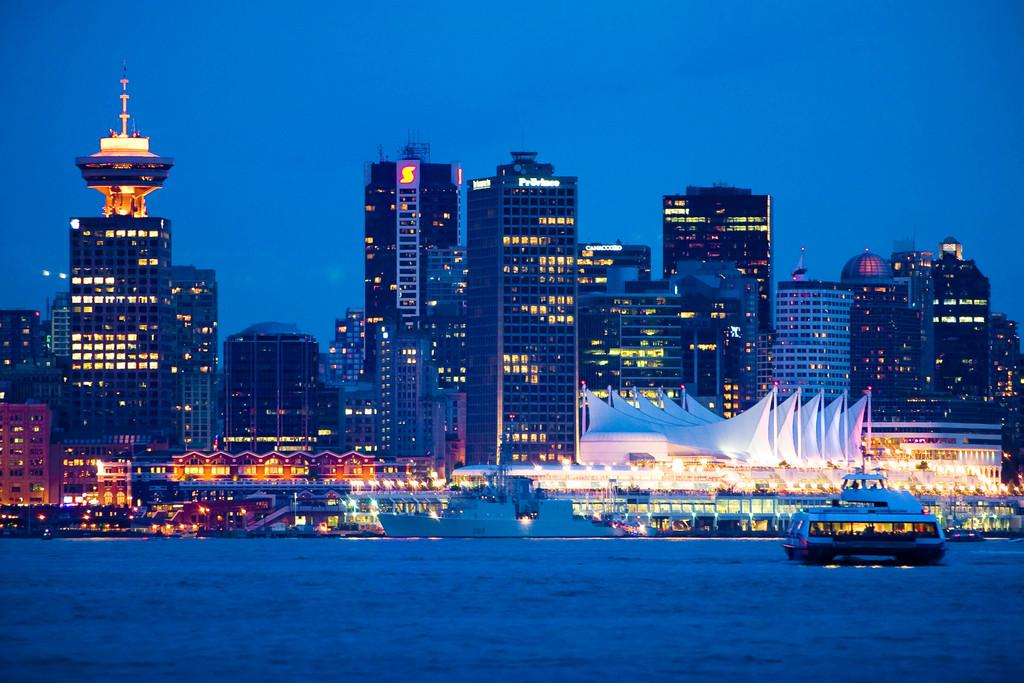What is the primary element visible in the image? There is water in the image. What type of vehicle is present on the right side of the image? There is a boat on the right side of the image. What type of structures can be seen in the background of the image? There are houses and tall buildings in the background of the image. How would you describe the sky in the image? The sky appears dull in the image. What type of oranges are being used as a spoon in the image? There are no oranges or spoons present in the image. What type of flag is being flown on the boat in the image? There is no flag visible on the boat in the image. 